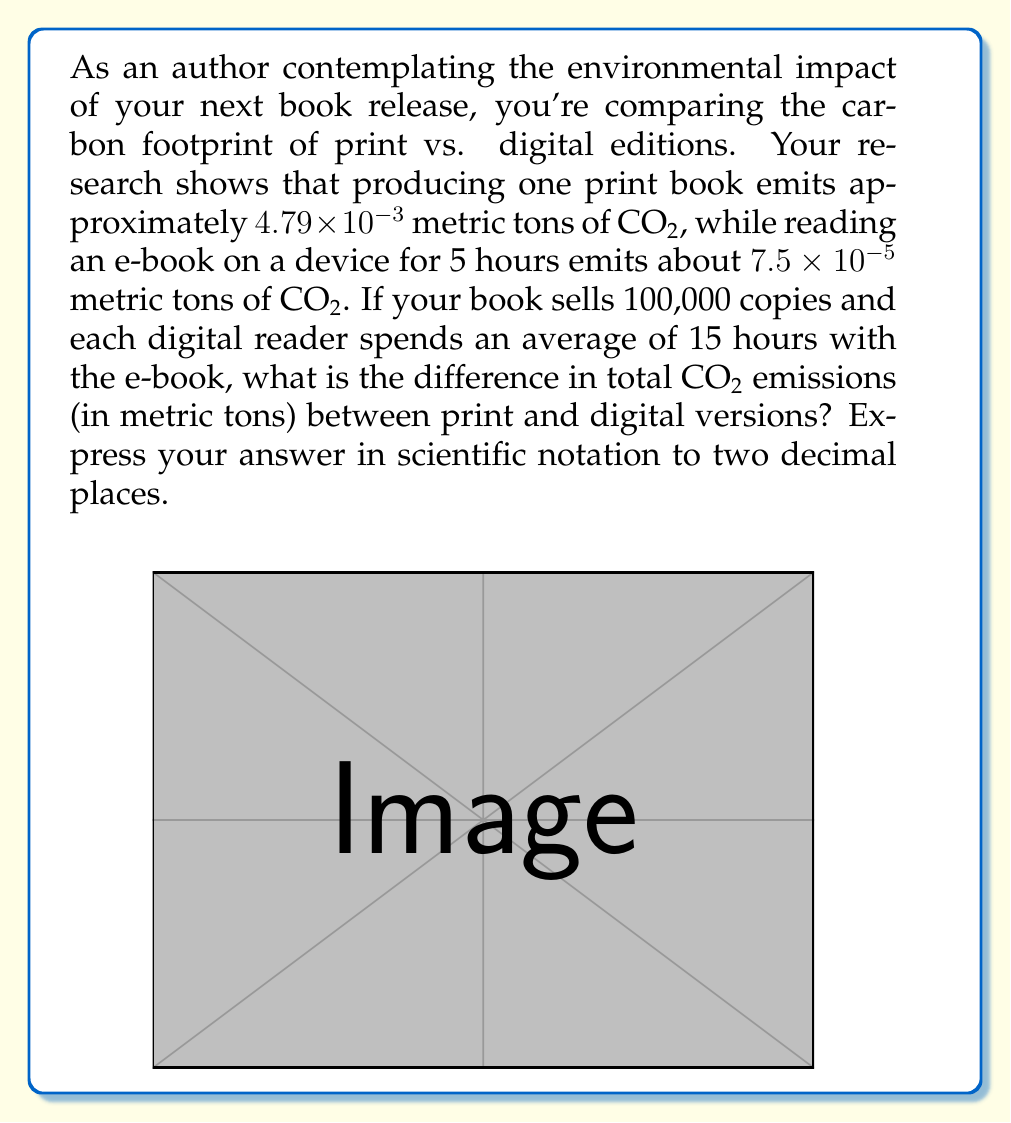Help me with this question. Let's approach this step-by-step:

1) Calculate total CO2 emissions for print books:
   $$100,000 \times 4.79 \times 10^{-3} = 479 \text{ metric tons of CO2}$$

2) Calculate CO2 emissions for e-books:
   - First, find emissions per 15 hours of reading:
     $$\frac{7.5 \times 10^{-5}}{5} \times 15 = 2.25 \times 10^{-4} \text{ metric tons of CO2 per e-book}$$
   - Then, multiply by the number of copies:
     $$100,000 \times 2.25 \times 10^{-4} = 22.5 \text{ metric tons of CO2}$$

3) Calculate the difference:
   $$479 - 22.5 = 456.5 \text{ metric tons of CO2}$$

4) Express the result in scientific notation to two decimal places:
   $$456.5 = 4.57 \times 10^2 \text{ metric tons of CO2}$$
Answer: $4.57 \times 10^2$ metric tons of CO2 